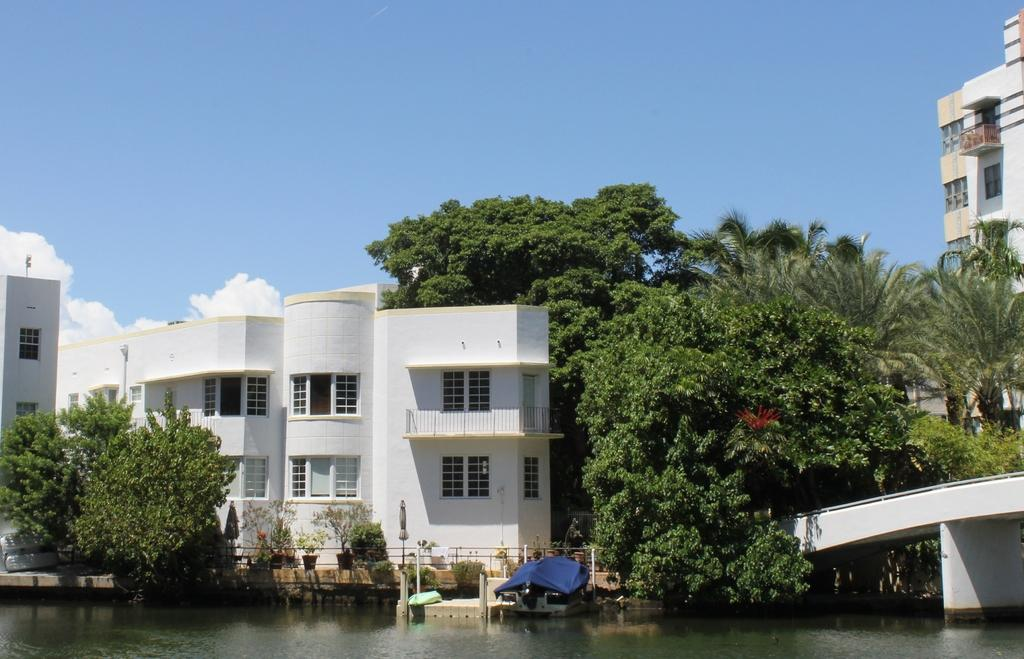What type of structures can be seen in the image? There are buildings in the image. What natural elements are present in the image? There are trees and water visible in the image. What architectural feature is present in the image? There is a bridge in the image. What is the weather like in the image? The sky is cloudy in the image. What type of vegetation is present in the image? There are plants in the image. What is the range of the learning experience for the trees in the image? There is no learning experience for the trees in the image, as trees do not have the ability to learn. 